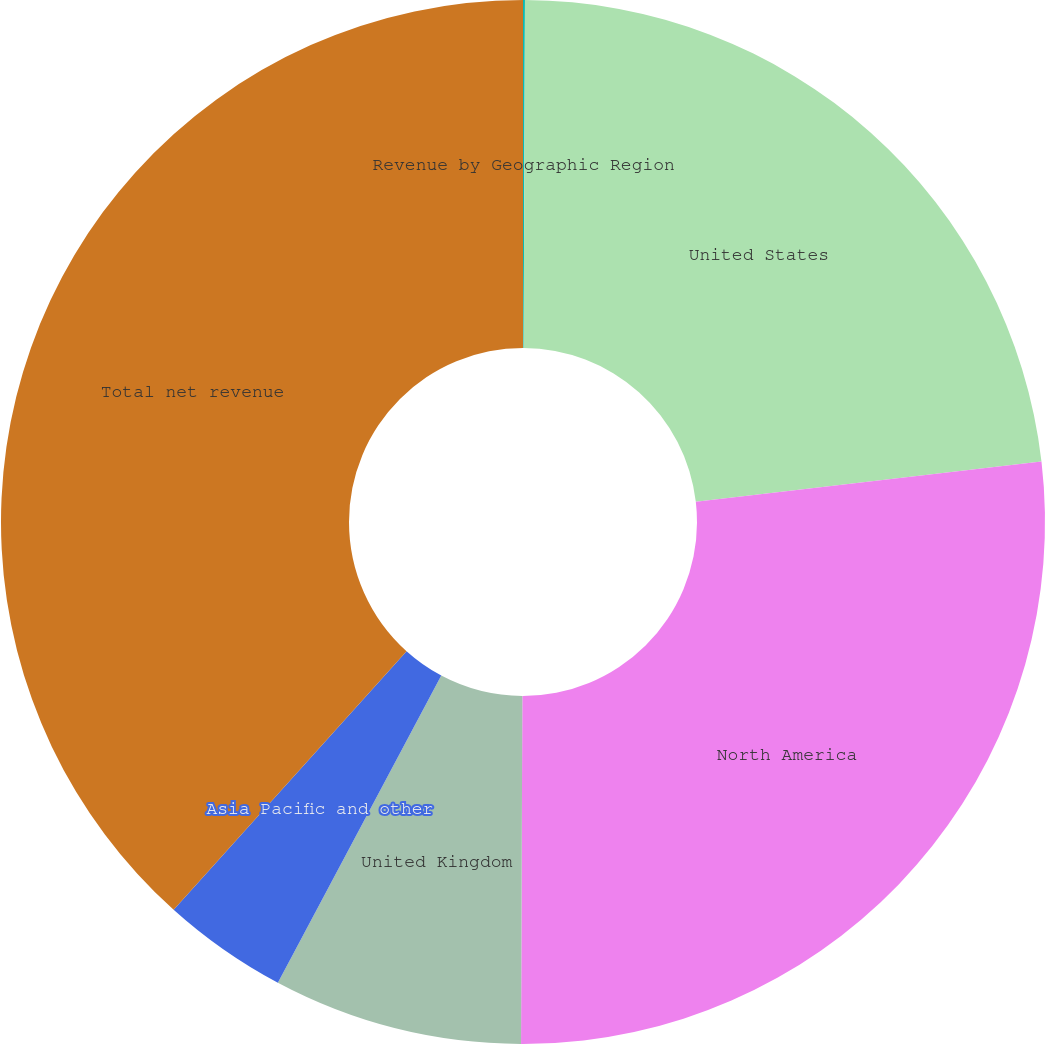Convert chart. <chart><loc_0><loc_0><loc_500><loc_500><pie_chart><fcel>Revenue by Geographic Region<fcel>United States<fcel>North America<fcel>United Kingdom<fcel>Asia Pacific and other<fcel>Total net revenue<nl><fcel>0.06%<fcel>23.09%<fcel>26.91%<fcel>7.72%<fcel>3.89%<fcel>38.33%<nl></chart> 